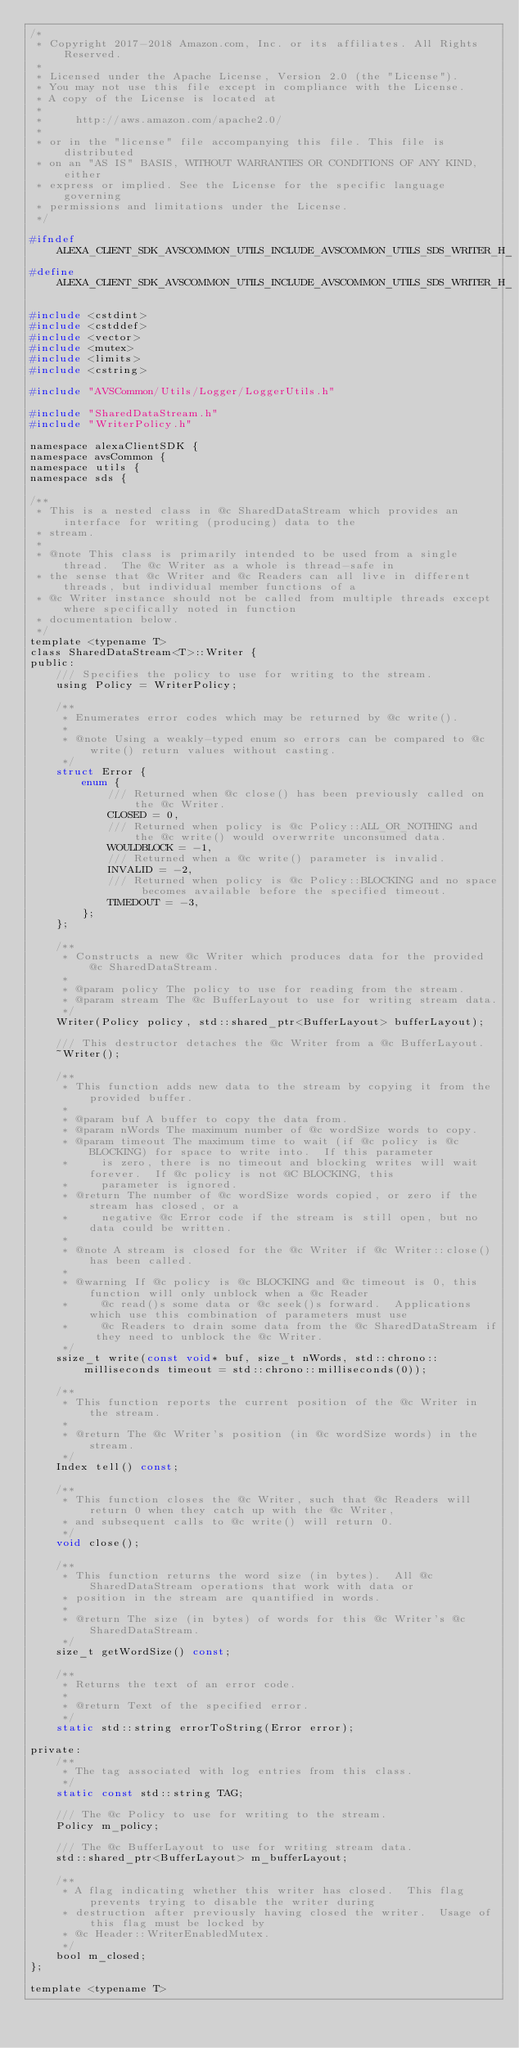Convert code to text. <code><loc_0><loc_0><loc_500><loc_500><_C_>/*
 * Copyright 2017-2018 Amazon.com, Inc. or its affiliates. All Rights Reserved.
 *
 * Licensed under the Apache License, Version 2.0 (the "License").
 * You may not use this file except in compliance with the License.
 * A copy of the License is located at
 *
 *     http://aws.amazon.com/apache2.0/
 *
 * or in the "license" file accompanying this file. This file is distributed
 * on an "AS IS" BASIS, WITHOUT WARRANTIES OR CONDITIONS OF ANY KIND, either
 * express or implied. See the License for the specific language governing
 * permissions and limitations under the License.
 */

#ifndef ALEXA_CLIENT_SDK_AVSCOMMON_UTILS_INCLUDE_AVSCOMMON_UTILS_SDS_WRITER_H_
#define ALEXA_CLIENT_SDK_AVSCOMMON_UTILS_INCLUDE_AVSCOMMON_UTILS_SDS_WRITER_H_

#include <cstdint>
#include <cstddef>
#include <vector>
#include <mutex>
#include <limits>
#include <cstring>

#include "AVSCommon/Utils/Logger/LoggerUtils.h"

#include "SharedDataStream.h"
#include "WriterPolicy.h"

namespace alexaClientSDK {
namespace avsCommon {
namespace utils {
namespace sds {

/**
 * This is a nested class in @c SharedDataStream which provides an interface for writing (producing) data to the
 * stream.
 *
 * @note This class is primarily intended to be used from a single thread.  The @c Writer as a whole is thread-safe in
 * the sense that @c Writer and @c Readers can all live in different threads, but individual member functions of a
 * @c Writer instance should not be called from multiple threads except where specifically noted in function
 * documentation below.
 */
template <typename T>
class SharedDataStream<T>::Writer {
public:
    /// Specifies the policy to use for writing to the stream.
    using Policy = WriterPolicy;

    /**
     * Enumerates error codes which may be returned by @c write().
     *
     * @note Using a weakly-typed enum so errors can be compared to @c write() return values without casting.
     */
    struct Error {
        enum {
            /// Returned when @c close() has been previously called on the @c Writer.
            CLOSED = 0,
            /// Returned when policy is @c Policy::ALL_OR_NOTHING and the @c write() would overwrrite unconsumed data.
            WOULDBLOCK = -1,
            /// Returned when a @c write() parameter is invalid.
            INVALID = -2,
            /// Returned when policy is @c Policy::BLOCKING and no space becomes available before the specified timeout.
            TIMEDOUT = -3,
        };
    };

    /**
     * Constructs a new @c Writer which produces data for the provided @c SharedDataStream.
     *
     * @param policy The policy to use for reading from the stream.
     * @param stream The @c BufferLayout to use for writing stream data.
     */
    Writer(Policy policy, std::shared_ptr<BufferLayout> bufferLayout);

    /// This destructor detaches the @c Writer from a @c BufferLayout.
    ~Writer();

    /**
     * This function adds new data to the stream by copying it from the provided buffer.
     *
     * @param buf A buffer to copy the data from.
     * @param nWords The maximum number of @c wordSize words to copy.
     * @param timeout The maximum time to wait (if @c policy is @c BLOCKING) for space to write into.  If this parameter
     *     is zero, there is no timeout and blocking writes will wait forever.  If @c policy is not @C BLOCKING, this
     *     parameter is ignored.
     * @return The number of @c wordSize words copied, or zero if the stream has closed, or a
     *     negative @c Error code if the stream is still open, but no data could be written.
     *
     * @note A stream is closed for the @c Writer if @c Writer::close() has been called.
     *
     * @warning If @c policy is @c BLOCKING and @c timeout is 0, this function will only unblock when a @c Reader
     *     @c read()s some data or @c seek()s forward.  Applications which use this combination of parameters must use
     *     @c Readers to drain some data from the @c SharedDataStream if they need to unblock the @c Writer.
     */
    ssize_t write(const void* buf, size_t nWords, std::chrono::milliseconds timeout = std::chrono::milliseconds(0));

    /**
     * This function reports the current position of the @c Writer in the stream.
     *
     * @return The @c Writer's position (in @c wordSize words) in the stream.
     */
    Index tell() const;

    /**
     * This function closes the @c Writer, such that @c Readers will return 0 when they catch up with the @c Writer,
     * and subsequent calls to @c write() will return 0.
     */
    void close();

    /**
     * This function returns the word size (in bytes).  All @c SharedDataStream operations that work with data or
     * position in the stream are quantified in words.
     *
     * @return The size (in bytes) of words for this @c Writer's @c SharedDataStream.
     */
    size_t getWordSize() const;

    /**
     * Returns the text of an error code.
     *
     * @return Text of the specified error.
     */
    static std::string errorToString(Error error);

private:
    /**
     * The tag associated with log entries from this class.
     */
    static const std::string TAG;

    /// The @c Policy to use for writing to the stream.
    Policy m_policy;

    /// The @c BufferLayout to use for writing stream data.
    std::shared_ptr<BufferLayout> m_bufferLayout;

    /**
     * A flag indicating whether this writer has closed.  This flag prevents trying to disable the writer during
     * destruction after previously having closed the writer.  Usage of this flag must be locked by
     * @c Header::WriterEnabledMutex.
     */
    bool m_closed;
};

template <typename T></code> 